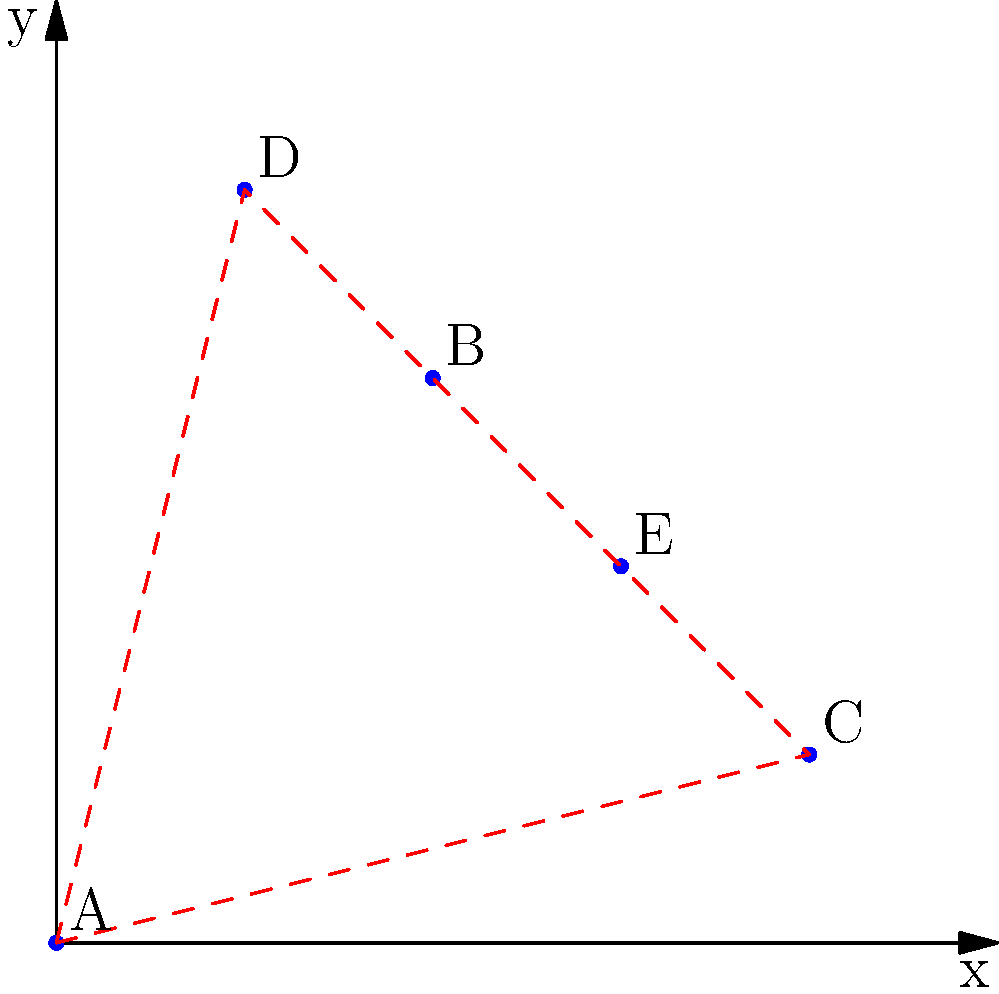As a law firm partner, you need to visit all five client locations (A, B, C, D, E) shown on the map. What is the optimal route that minimizes travel distance, assuming you start and end at location A? To determine the optimal route, we need to analyze the spatial distribution of the clients and find the shortest path that visits all locations:

1. Start at location A (0,0).
2. The closest point to A is D (1,4), so we move to D.
3. From D, the nearest unvisited point is B (2,3).
4. After B, the closest remaining point is E (3,2).
5. From E, we move to the last unvisited point, C (4,1).
6. Finally, we return to the starting point A.

This route follows the principle of the nearest neighbor algorithm, which is a heuristic method for solving the Traveling Salesman Problem. While it may not always produce the absolute optimal solution, it generally provides a good approximation and is efficient to calculate.

The resulting path is: A → D → B → E → C → A

This route minimizes the total travel distance while ensuring all client locations are visited exactly once before returning to the starting point.
Answer: A → D → B → E → C → A 